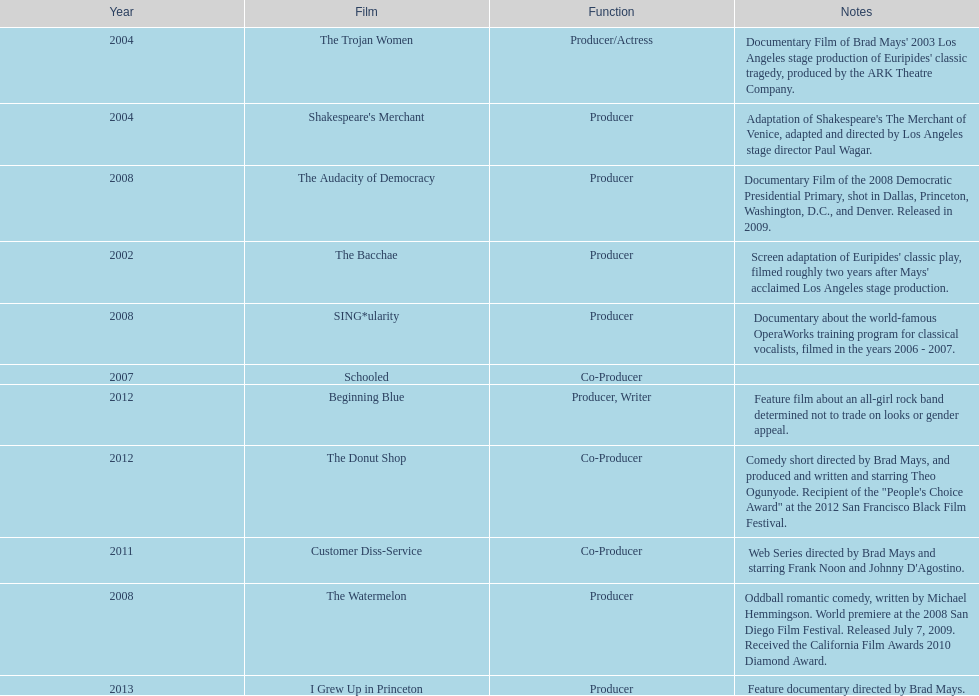After 2010, how many movies were produced by ms. starfelt? 4. 